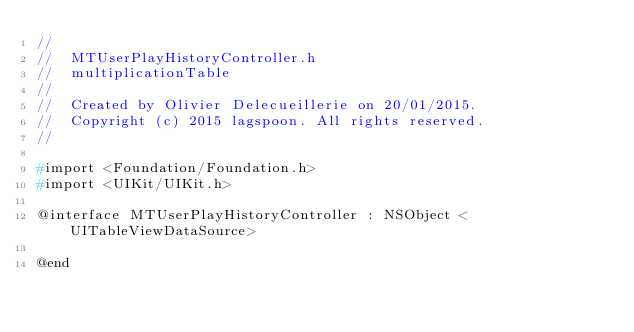<code> <loc_0><loc_0><loc_500><loc_500><_C_>//
//  MTUserPlayHistoryController.h
//  multiplicationTable
//
//  Created by Olivier Delecueillerie on 20/01/2015.
//  Copyright (c) 2015 lagspoon. All rights reserved.
//

#import <Foundation/Foundation.h>
#import <UIKit/UIKit.h> 

@interface MTUserPlayHistoryController : NSObject <UITableViewDataSource>

@end
</code> 